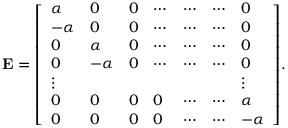Convert formula to latex. <formula><loc_0><loc_0><loc_500><loc_500>E = { \left [ \begin{array} { l l l l l l l } { \alpha } & { 0 } & { 0 } & { \cdots } & { \cdots } & { \cdots } & { 0 } \\ { - \alpha } & { 0 } & { 0 } & { \cdots } & { \cdots } & { \cdots } & { 0 } \\ { 0 } & { \alpha } & { 0 } & { \cdots } & { \cdots } & { \cdots } & { 0 } \\ { 0 } & { - \alpha } & { 0 } & { \cdots } & { \cdots } & { \cdots } & { 0 } \\ { \vdots } & { \vdots } \\ { 0 } & { 0 } & { 0 } & { 0 } & { \cdots } & { \cdots } & { \alpha } \\ { 0 } & { 0 } & { 0 } & { 0 } & { \cdots } & { \cdots } & { - \alpha } \end{array} \right ] } .</formula> 